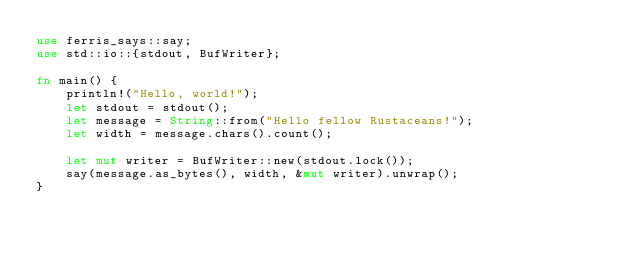Convert code to text. <code><loc_0><loc_0><loc_500><loc_500><_Rust_>use ferris_says::say;
use std::io::{stdout, BufWriter};

fn main() {
    println!("Hello, world!");
    let stdout = stdout();
    let message = String::from("Hello fellow Rustaceans!");
    let width = message.chars().count();

    let mut writer = BufWriter::new(stdout.lock());
    say(message.as_bytes(), width, &mut writer).unwrap();
}

</code> 